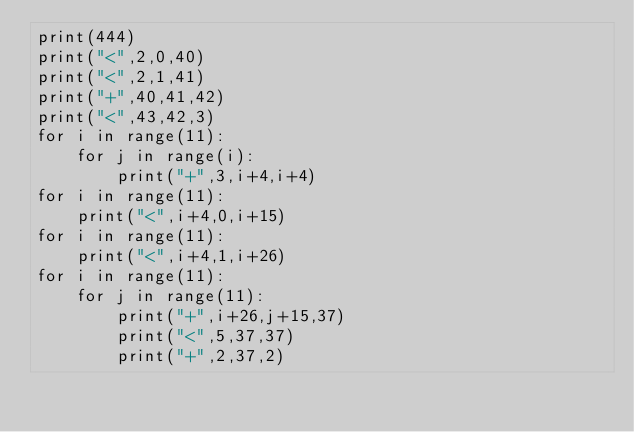<code> <loc_0><loc_0><loc_500><loc_500><_Python_>print(444)
print("<",2,0,40)
print("<",2,1,41)
print("+",40,41,42)
print("<",43,42,3)
for i in range(11):
    for j in range(i):
        print("+",3,i+4,i+4)
for i in range(11):
    print("<",i+4,0,i+15)
for i in range(11):
    print("<",i+4,1,i+26)
for i in range(11):
    for j in range(11):
        print("+",i+26,j+15,37)
        print("<",5,37,37)
        print("+",2,37,2)
</code> 